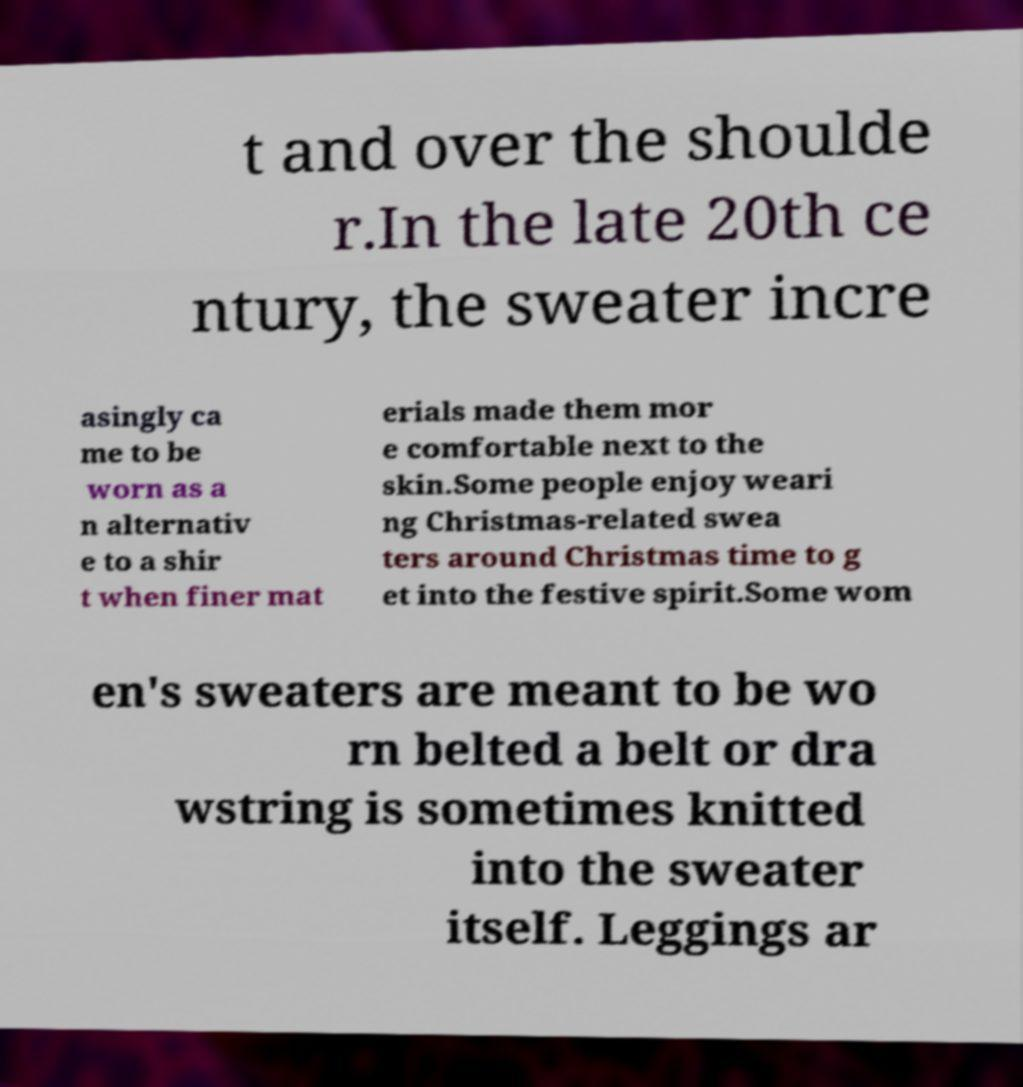Could you assist in decoding the text presented in this image and type it out clearly? t and over the shoulde r.In the late 20th ce ntury, the sweater incre asingly ca me to be worn as a n alternativ e to a shir t when finer mat erials made them mor e comfortable next to the skin.Some people enjoy weari ng Christmas-related swea ters around Christmas time to g et into the festive spirit.Some wom en's sweaters are meant to be wo rn belted a belt or dra wstring is sometimes knitted into the sweater itself. Leggings ar 